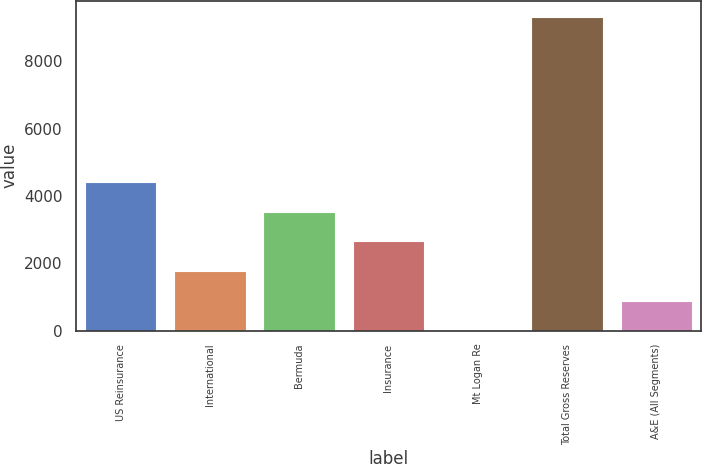Convert chart. <chart><loc_0><loc_0><loc_500><loc_500><bar_chart><fcel>US Reinsurance<fcel>International<fcel>Bermuda<fcel>Insurance<fcel>Mt Logan Re<fcel>Total Gross Reserves<fcel>A&E (All Segments)<nl><fcel>4412.25<fcel>1767.48<fcel>3530.66<fcel>2649.07<fcel>4.3<fcel>9327.79<fcel>885.89<nl></chart> 